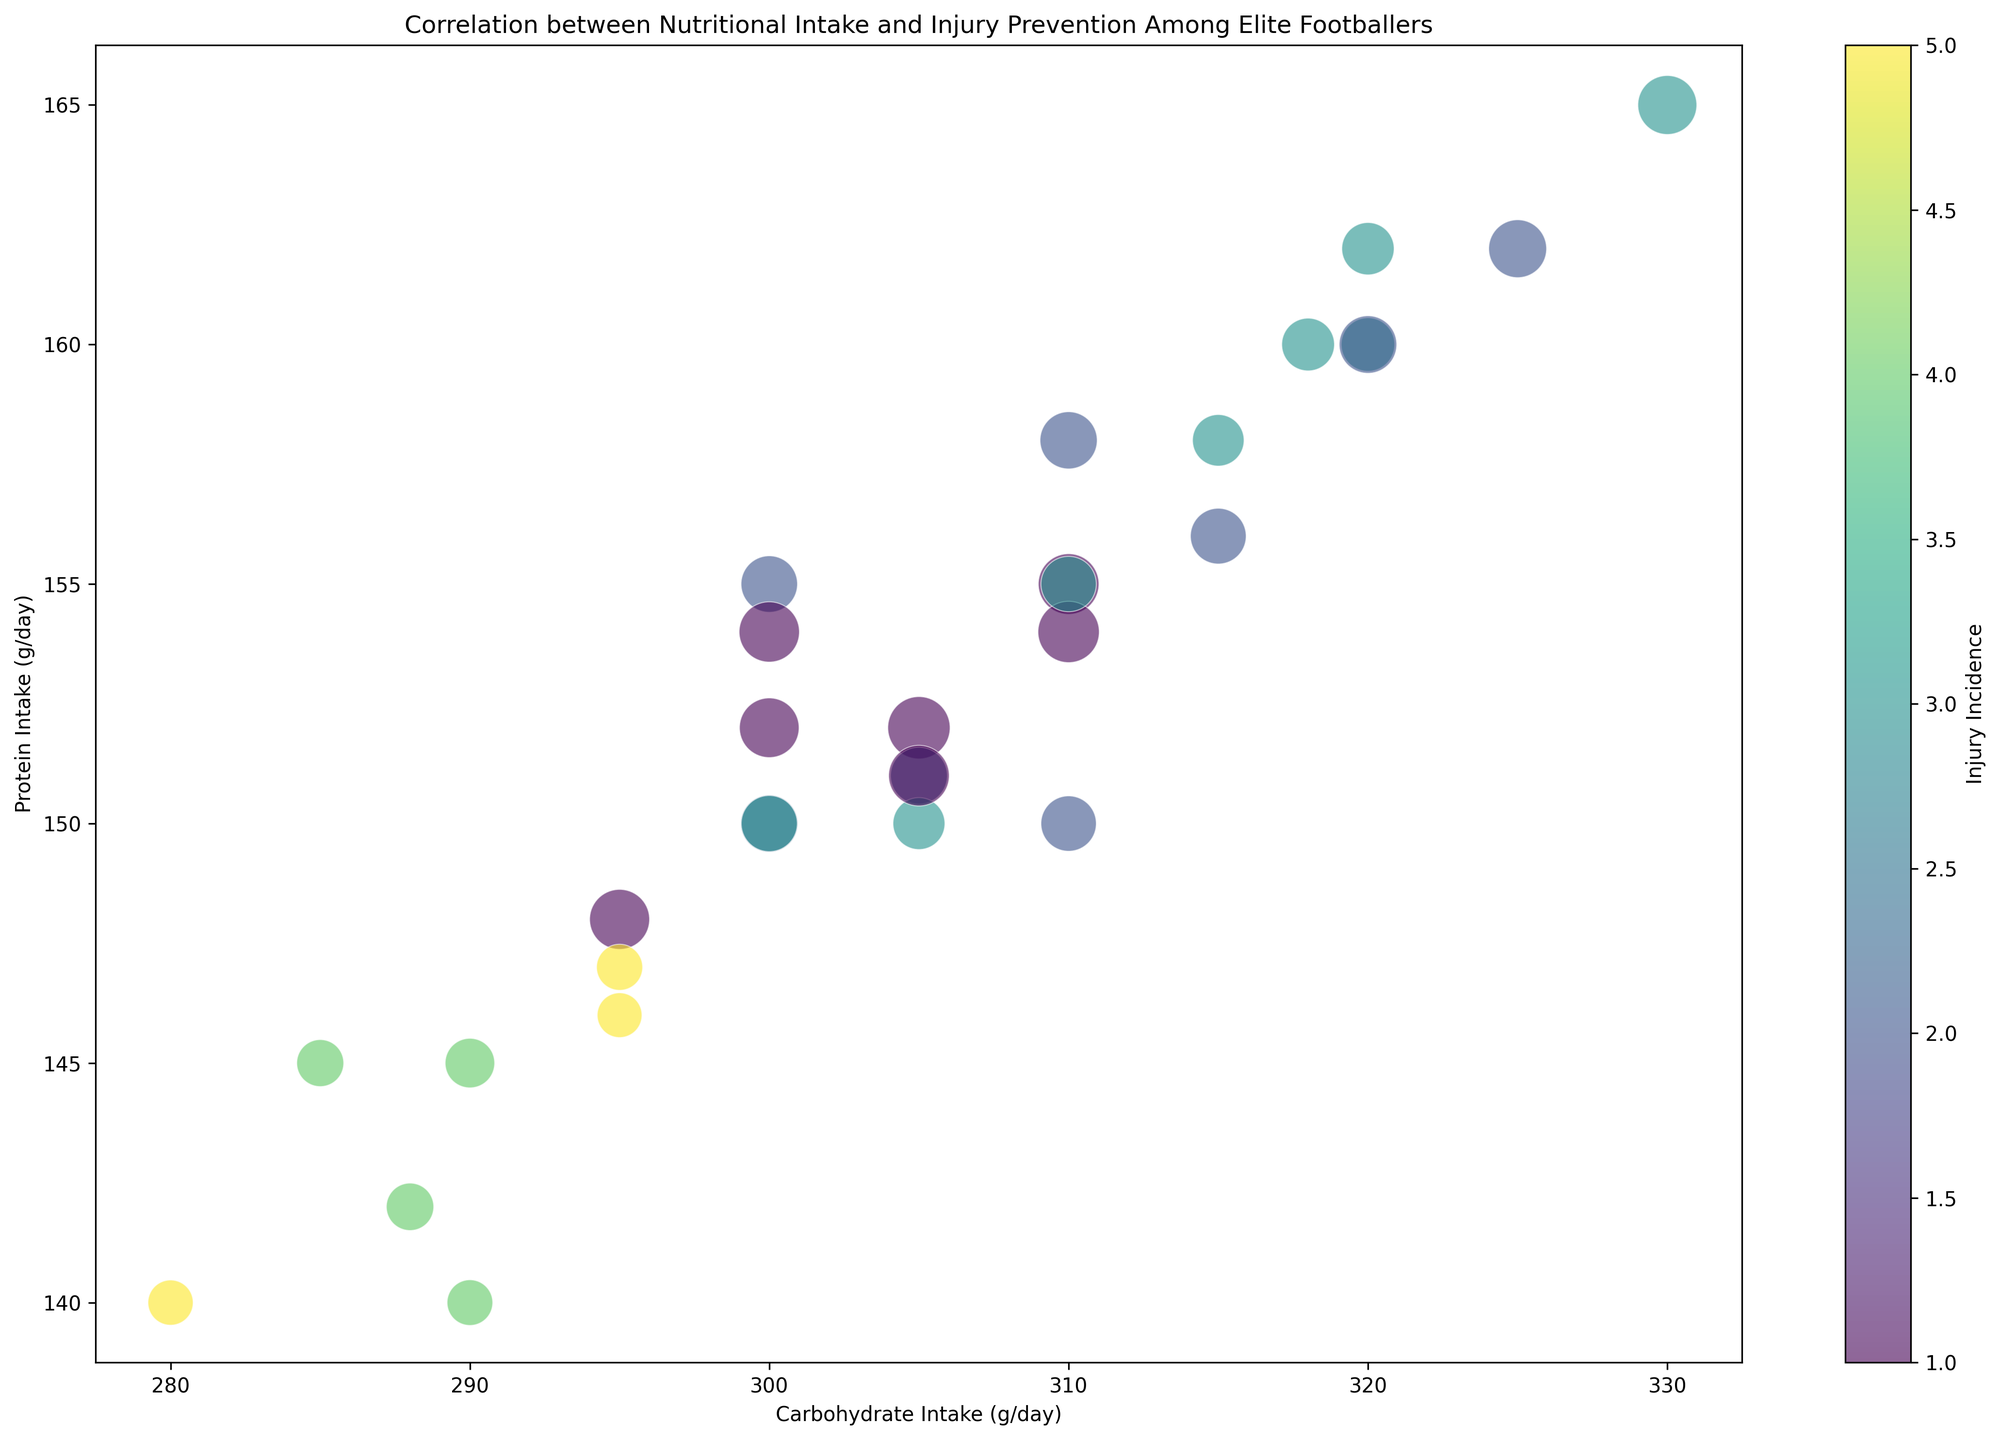What's the general relationship between carbohydrate intake and protein intake as shown in the plot? By observing the scatter position, it appears that as carbohydrate intake increases, protein intake typically increases as well. Most dots are aligned along a positively sloped trend.
Answer: Positive correlation Which player has the highest injury incidence and what is their carbohydrate and protein intake? The color with the highest value on the color bar corresponds to the highest injury incidence. The player with the highest incidence (5) can be identified visually by the darkest bubble. Checking the respective position shows that Players 8, 18, and 25 have this highest injury incidence value. Player 8 has a carbohydrate intake of 280 g/day and protein intake of 140 g/day; Player 18 has 295 g/day and 147 g/day respectively; Player 25 has 295 g/day and 146 g/day respectively.
Answer: Players 8: 280, 140; Player 18: 295, 147; Player 25: 295, 146 Comparing Player 5 and Player 14, which one has a higher importance score and by what margin? From the bubble sizes, we can see Player 5 (bigger bubble) has a higher importance score than Player 14 (smaller bubble). From the data, Player 5 has an importance of 95 and Player 14 has 77. The margin is calculated as 95 - 77.
Answer: 18 What is the carbohydrate intake range within the dataset? By observing the x-axis tick marks and the spread of the bubbles, the minimum and maximum values of carbohydrate intake data ranged from 280 to 330.
Answer: 280-330 g/day Which players have the lowest injury incidence and how many protein grams do they consume daily? The brightest colored bubbles represent the lowest injury incidence (1). By checking the visual representation, we see bubbles at 1 (Protein Intake vs Injury Incidence), we find Players 3, 5, 9, 15, 19, 26, and 30. Their protein intakes are 155, 152, 148, 154, 152, 154, and 151 respectively.
Answer: 155, 152, 148, 154, 152, 154, 151 g/day 